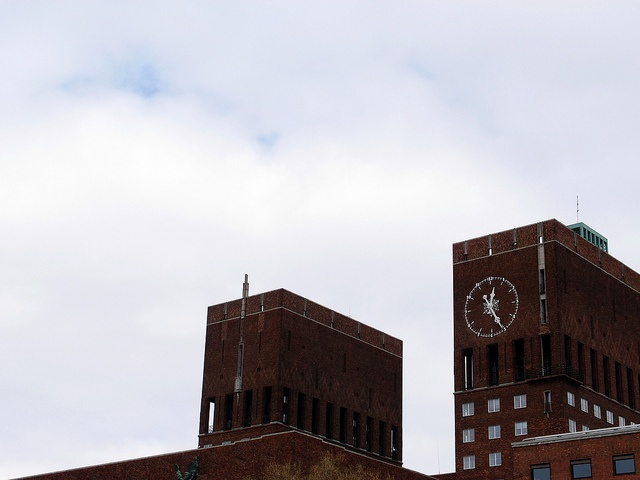Describe the objects in this image and their specific colors. I can see a clock in lavender, black, gray, and darkgray tones in this image. 